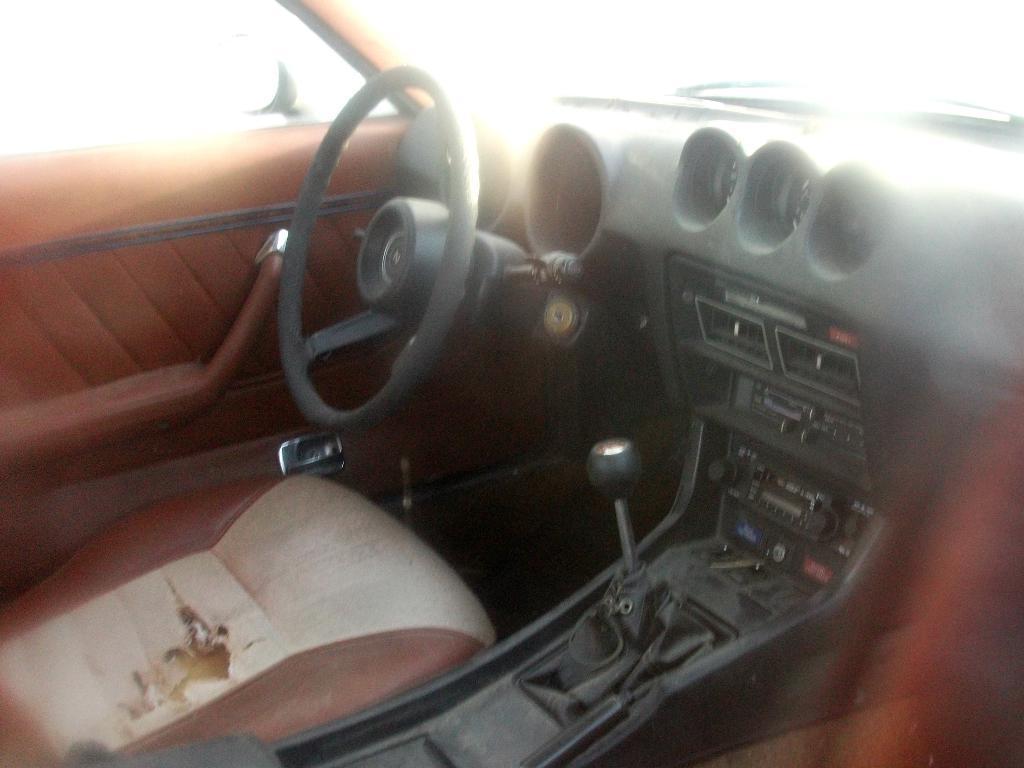Could you give a brief overview of what you see in this image? The image is captured from inside a car, there is a steering, speedometer, gear and many more parts inside a car. 